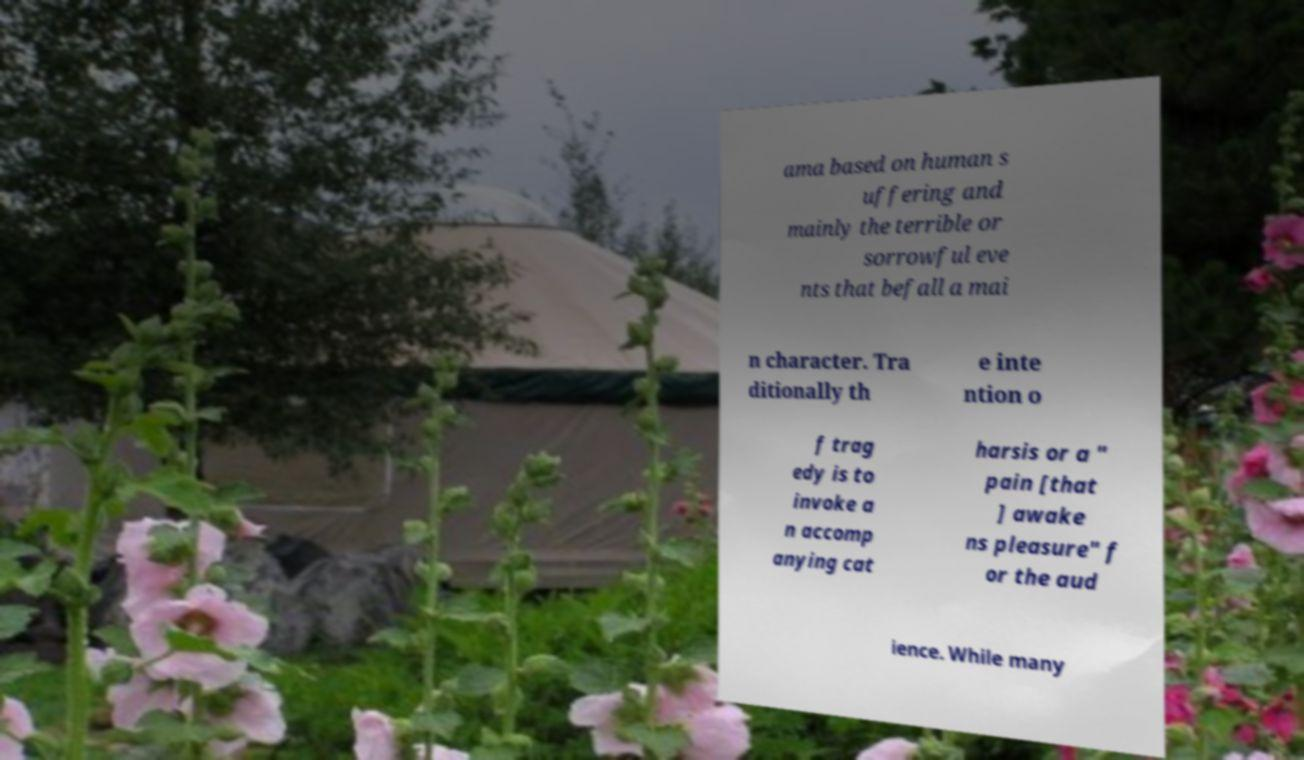I need the written content from this picture converted into text. Can you do that? ama based on human s uffering and mainly the terrible or sorrowful eve nts that befall a mai n character. Tra ditionally th e inte ntion o f trag edy is to invoke a n accomp anying cat harsis or a " pain [that ] awake ns pleasure" f or the aud ience. While many 